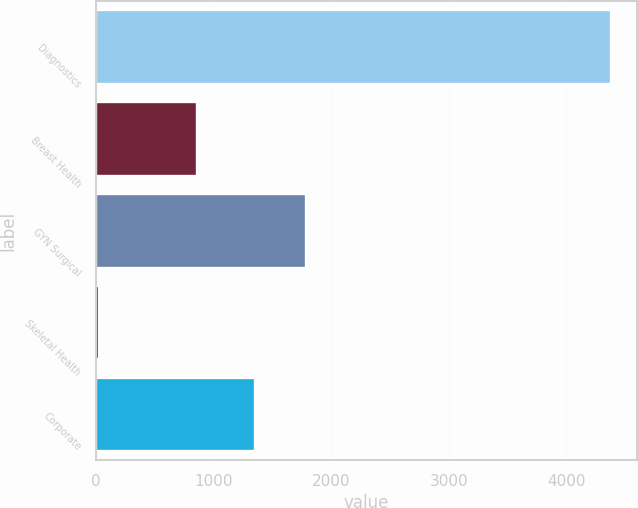Convert chart. <chart><loc_0><loc_0><loc_500><loc_500><bar_chart><fcel>Diagnostics<fcel>Breast Health<fcel>GYN Surgical<fcel>Skeletal Health<fcel>Corporate<nl><fcel>4383.5<fcel>859.8<fcel>1786.84<fcel>26.1<fcel>1351.1<nl></chart> 